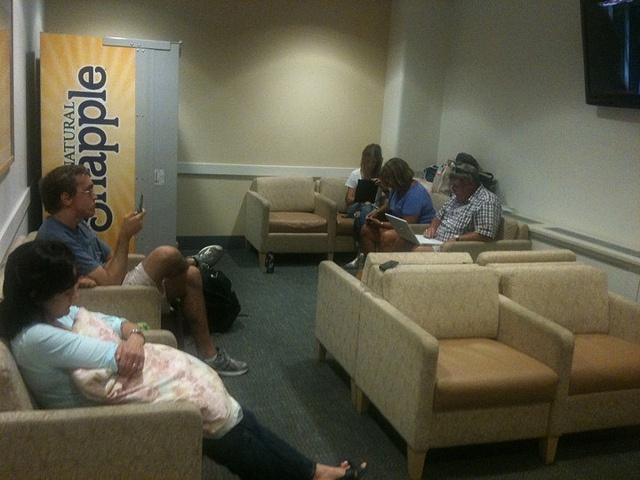Describe the objects in this image and their specific colors. I can see chair in gray, black, and olive tones, refrigerator in gray, darkgray, and tan tones, people in gray, black, darkgray, and lightgray tones, chair in gray and black tones, and chair in gray, olive, and black tones in this image. 